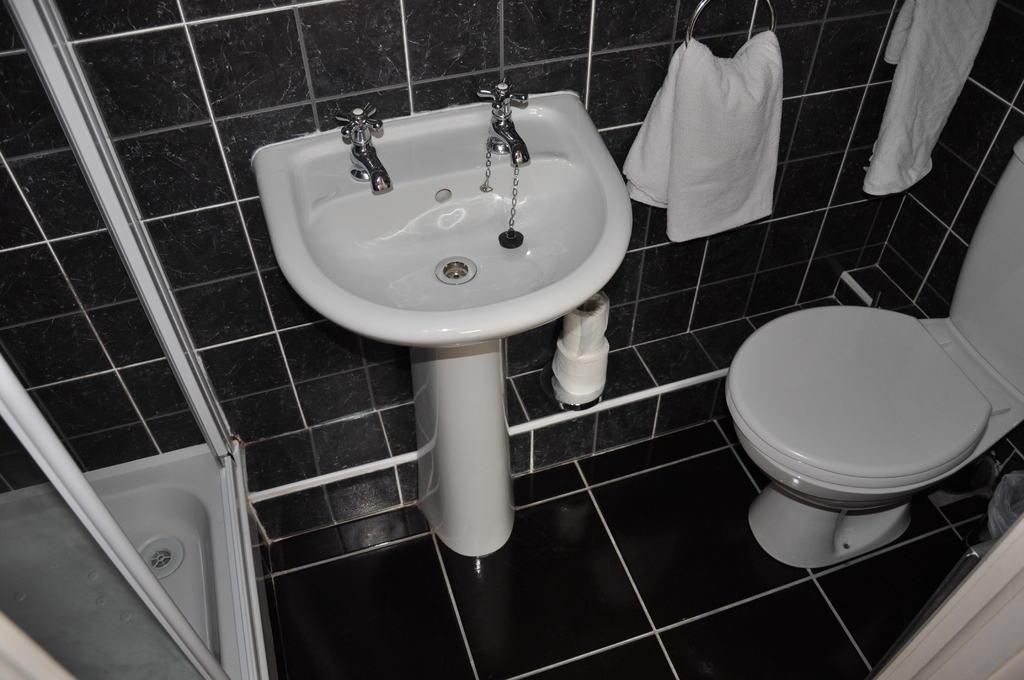What type of fixture is present in the image for washing hands or other purposes? There is a basin in the image, which is typically used for washing hands or other purposes. What is used to control the flow of water in the basin? There are water taps in the image, which are used to control the flow of water. What type of toilet is present in the image? There is a western toilet in the image. What items are present for cleaning or wiping in the image? There is a napkin and a tissue roll in the image. What is the large, tub-like fixture in the image used for? There is a bathtub in the image, which is used for bathing or soaking. What part of the room can be seen in the image? The floor and the wall are visible in the image. What type of iron is used for pressing clothes in the image? There is no iron present in the image. Where is the vacation spot depicted in the image? The image does not depict a vacation spot; it shows a bathroom with a basin, water taps, a toilet, a napkin, a tissue roll, a bathtub, the floor, and the wall. What type of club is shown in the image? There is no club present in the image. 